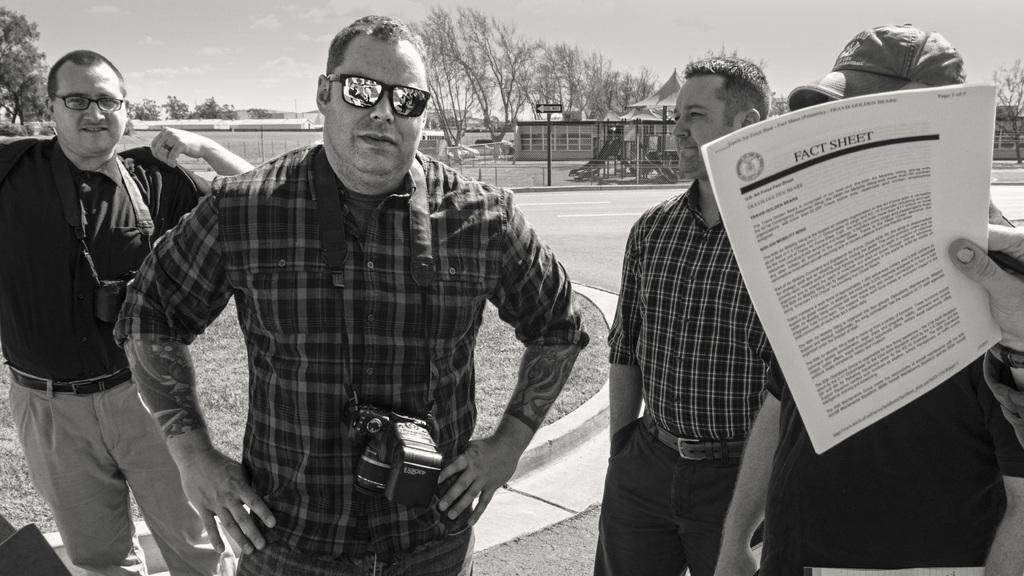Can you describe this image briefly? This is a black and white picture. Here we can see four persons, papers, and cameras. There is a road. Here we can see grass, poles, board, trees, and sheds. In the background there is sky. 